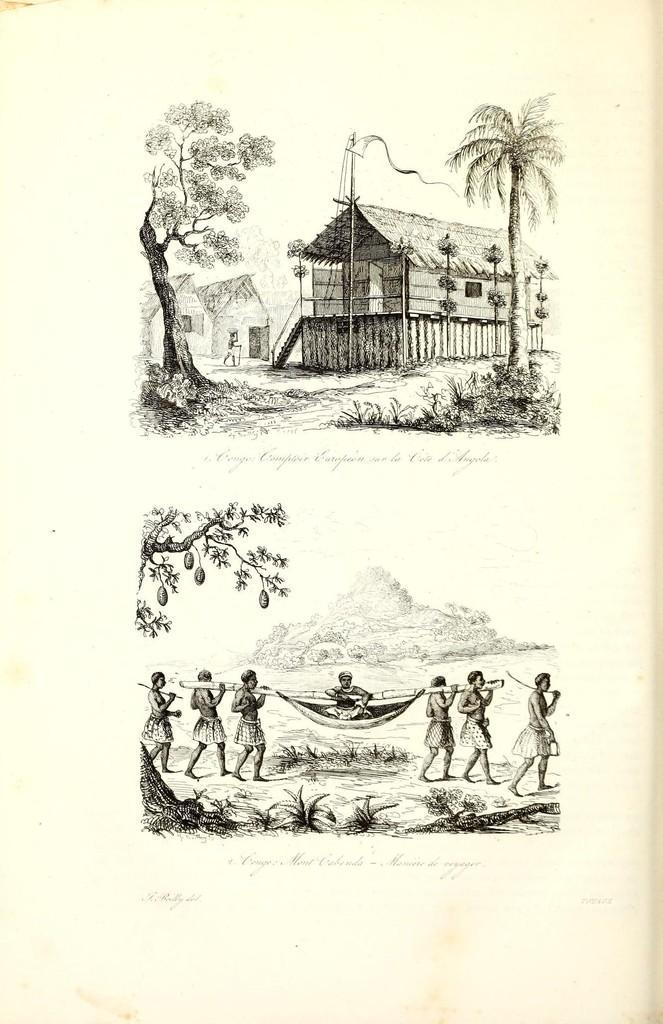Can you describe this image briefly? In this image, we can see two pictures, at the bottom we can see some people walking and at the top we can see a homes and some trees. 